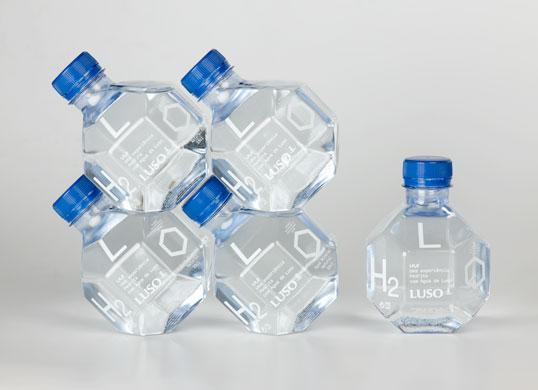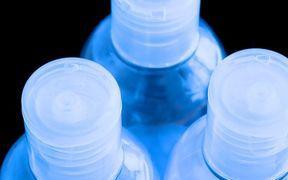The first image is the image on the left, the second image is the image on the right. For the images shown, is this caption "An image shows multiple water bottles surrounded by ice cubes." true? Answer yes or no. No. The first image is the image on the left, the second image is the image on the right. Evaluate the accuracy of this statement regarding the images: "At least three of the bottles in one of the images has a blue cap.". Is it true? Answer yes or no. Yes. 